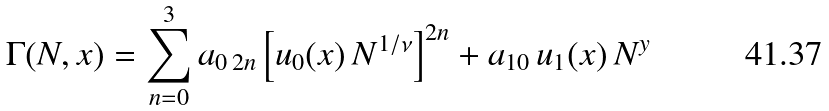<formula> <loc_0><loc_0><loc_500><loc_500>\Gamma ( N , x ) = \sum _ { n = 0 } ^ { 3 } a _ { 0 \, 2 n } \left [ u _ { 0 } ( x ) \, N ^ { 1 / \nu } \right ] ^ { 2 n } + a _ { 1 0 } \, u _ { 1 } ( x ) \, N ^ { y }</formula> 